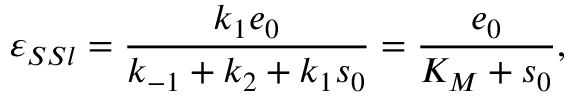<formula> <loc_0><loc_0><loc_500><loc_500>\varepsilon _ { S S l } = \frac { k _ { 1 } e _ { 0 } } { k _ { - 1 } + k _ { 2 } + k _ { 1 } s _ { 0 } } = \frac { e _ { 0 } } { K _ { M } + s _ { 0 } } ,</formula> 